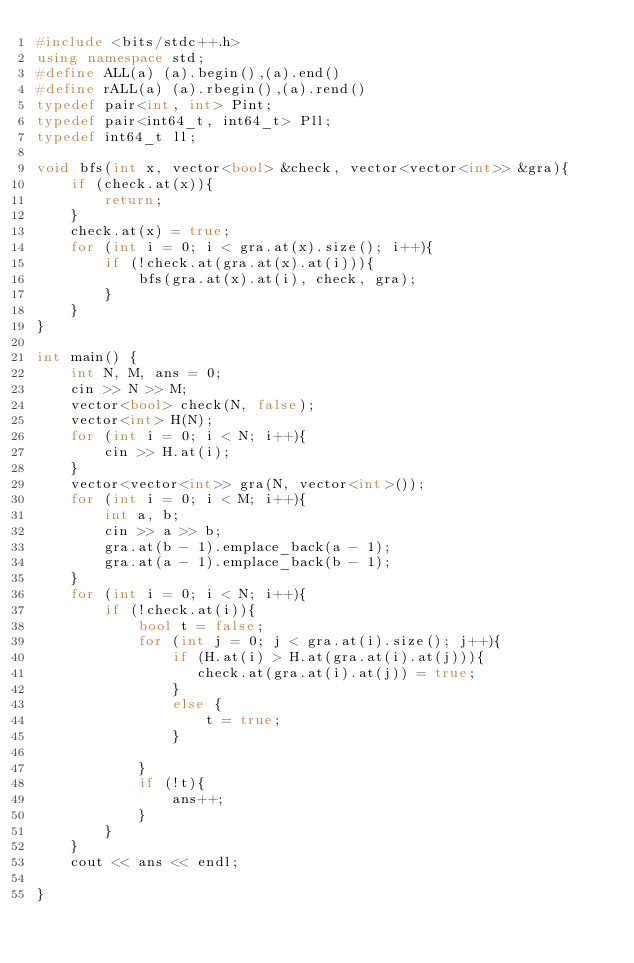Convert code to text. <code><loc_0><loc_0><loc_500><loc_500><_C++_>#include <bits/stdc++.h>
using namespace std;
#define ALL(a) (a).begin(),(a).end()
#define rALL(a) (a).rbegin(),(a).rend()
typedef pair<int, int> Pint;
typedef pair<int64_t, int64_t> Pll;
typedef int64_t ll;

void bfs(int x, vector<bool> &check, vector<vector<int>> &gra){
    if (check.at(x)){
        return;
    }
    check.at(x) = true;
    for (int i = 0; i < gra.at(x).size(); i++){
        if (!check.at(gra.at(x).at(i))){
            bfs(gra.at(x).at(i), check, gra);
        }
    }
} 

int main() {
    int N, M, ans = 0;
    cin >> N >> M;
    vector<bool> check(N, false);
    vector<int> H(N);
    for (int i = 0; i < N; i++){
        cin >> H.at(i);
    }
    vector<vector<int>> gra(N, vector<int>());
    for (int i = 0; i < M; i++){
        int a, b;
        cin >> a >> b;
        gra.at(b - 1).emplace_back(a - 1);
        gra.at(a - 1).emplace_back(b - 1);
    }
    for (int i = 0; i < N; i++){
        if (!check.at(i)){
            bool t = false;
            for (int j = 0; j < gra.at(i).size(); j++){
                if (H.at(i) > H.at(gra.at(i).at(j))){
                   check.at(gra.at(i).at(j)) = true; 
                }
                else {
                    t = true;
                }
                
            }
            if (!t){
                ans++;
            }
        }
    }
    cout << ans << endl;

}</code> 